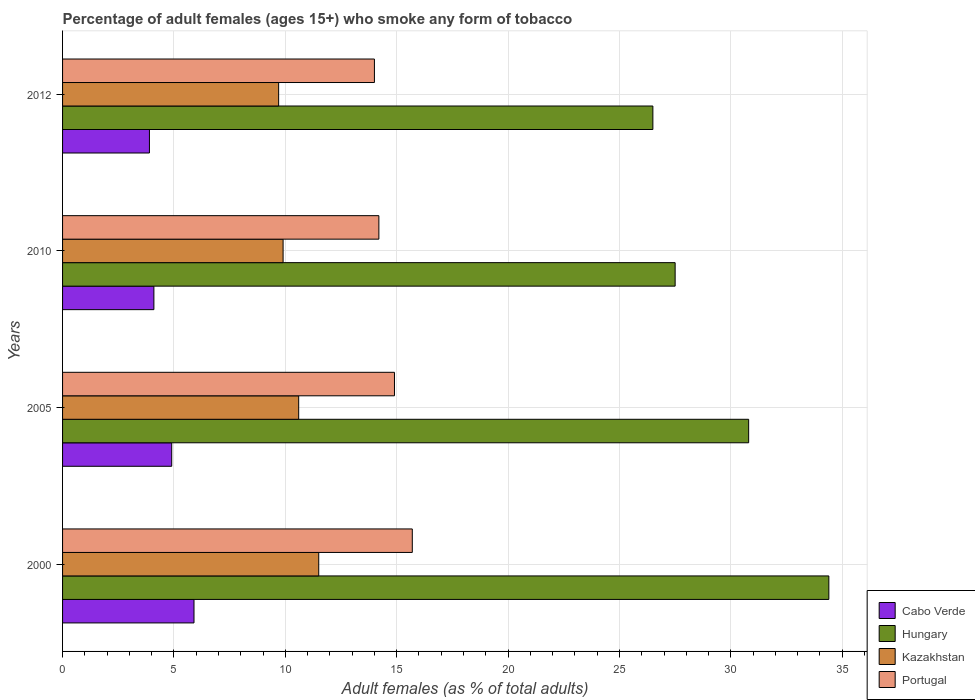How many groups of bars are there?
Provide a short and direct response. 4. How many bars are there on the 1st tick from the bottom?
Offer a terse response. 4. What is the percentage of adult females who smoke in Cabo Verde in 2005?
Keep it short and to the point. 4.9. Across all years, what is the maximum percentage of adult females who smoke in Hungary?
Your answer should be compact. 34.4. In which year was the percentage of adult females who smoke in Kazakhstan maximum?
Your answer should be very brief. 2000. What is the total percentage of adult females who smoke in Portugal in the graph?
Your response must be concise. 58.8. What is the difference between the percentage of adult females who smoke in Kazakhstan in 2005 and that in 2010?
Your answer should be compact. 0.7. What is the difference between the percentage of adult females who smoke in Hungary in 2005 and the percentage of adult females who smoke in Kazakhstan in 2012?
Give a very brief answer. 21.1. What is the average percentage of adult females who smoke in Hungary per year?
Ensure brevity in your answer.  29.8. In the year 2005, what is the difference between the percentage of adult females who smoke in Kazakhstan and percentage of adult females who smoke in Hungary?
Provide a succinct answer. -20.2. In how many years, is the percentage of adult females who smoke in Hungary greater than 14 %?
Provide a succinct answer. 4. What is the ratio of the percentage of adult females who smoke in Portugal in 2005 to that in 2010?
Offer a very short reply. 1.05. Is the percentage of adult females who smoke in Cabo Verde in 2005 less than that in 2012?
Make the answer very short. No. Is the difference between the percentage of adult females who smoke in Kazakhstan in 2000 and 2010 greater than the difference between the percentage of adult females who smoke in Hungary in 2000 and 2010?
Your response must be concise. No. What is the difference between the highest and the lowest percentage of adult females who smoke in Hungary?
Offer a terse response. 7.9. Is it the case that in every year, the sum of the percentage of adult females who smoke in Hungary and percentage of adult females who smoke in Portugal is greater than the sum of percentage of adult females who smoke in Cabo Verde and percentage of adult females who smoke in Kazakhstan?
Provide a short and direct response. No. What does the 2nd bar from the top in 2012 represents?
Make the answer very short. Kazakhstan. Is it the case that in every year, the sum of the percentage of adult females who smoke in Hungary and percentage of adult females who smoke in Cabo Verde is greater than the percentage of adult females who smoke in Kazakhstan?
Give a very brief answer. Yes. How many bars are there?
Make the answer very short. 16. Are the values on the major ticks of X-axis written in scientific E-notation?
Make the answer very short. No. Does the graph contain any zero values?
Offer a terse response. No. Where does the legend appear in the graph?
Provide a succinct answer. Bottom right. What is the title of the graph?
Provide a short and direct response. Percentage of adult females (ages 15+) who smoke any form of tobacco. Does "Cayman Islands" appear as one of the legend labels in the graph?
Your response must be concise. No. What is the label or title of the X-axis?
Offer a very short reply. Adult females (as % of total adults). What is the label or title of the Y-axis?
Make the answer very short. Years. What is the Adult females (as % of total adults) in Hungary in 2000?
Ensure brevity in your answer.  34.4. What is the Adult females (as % of total adults) of Kazakhstan in 2000?
Offer a terse response. 11.5. What is the Adult females (as % of total adults) of Cabo Verde in 2005?
Your answer should be very brief. 4.9. What is the Adult females (as % of total adults) of Hungary in 2005?
Keep it short and to the point. 30.8. What is the Adult females (as % of total adults) of Cabo Verde in 2010?
Ensure brevity in your answer.  4.1. What is the Adult females (as % of total adults) of Kazakhstan in 2010?
Your response must be concise. 9.9. What is the Adult females (as % of total adults) in Cabo Verde in 2012?
Make the answer very short. 3.9. What is the Adult females (as % of total adults) of Portugal in 2012?
Provide a short and direct response. 14. Across all years, what is the maximum Adult females (as % of total adults) of Cabo Verde?
Your response must be concise. 5.9. Across all years, what is the maximum Adult females (as % of total adults) of Hungary?
Your answer should be very brief. 34.4. Across all years, what is the minimum Adult females (as % of total adults) in Cabo Verde?
Provide a short and direct response. 3.9. Across all years, what is the minimum Adult females (as % of total adults) in Hungary?
Your answer should be very brief. 26.5. What is the total Adult females (as % of total adults) of Cabo Verde in the graph?
Keep it short and to the point. 18.8. What is the total Adult females (as % of total adults) of Hungary in the graph?
Your response must be concise. 119.2. What is the total Adult females (as % of total adults) in Kazakhstan in the graph?
Make the answer very short. 41.7. What is the total Adult females (as % of total adults) in Portugal in the graph?
Offer a very short reply. 58.8. What is the difference between the Adult females (as % of total adults) in Cabo Verde in 2000 and that in 2005?
Offer a very short reply. 1. What is the difference between the Adult females (as % of total adults) in Hungary in 2000 and that in 2010?
Your answer should be compact. 6.9. What is the difference between the Adult females (as % of total adults) in Cabo Verde in 2000 and that in 2012?
Provide a short and direct response. 2. What is the difference between the Adult females (as % of total adults) of Portugal in 2005 and that in 2010?
Your response must be concise. 0.7. What is the difference between the Adult females (as % of total adults) of Cabo Verde in 2005 and that in 2012?
Provide a succinct answer. 1. What is the difference between the Adult females (as % of total adults) of Hungary in 2005 and that in 2012?
Ensure brevity in your answer.  4.3. What is the difference between the Adult females (as % of total adults) in Portugal in 2005 and that in 2012?
Make the answer very short. 0.9. What is the difference between the Adult females (as % of total adults) in Hungary in 2010 and that in 2012?
Your response must be concise. 1. What is the difference between the Adult females (as % of total adults) of Kazakhstan in 2010 and that in 2012?
Your answer should be very brief. 0.2. What is the difference between the Adult females (as % of total adults) in Portugal in 2010 and that in 2012?
Provide a succinct answer. 0.2. What is the difference between the Adult females (as % of total adults) in Cabo Verde in 2000 and the Adult females (as % of total adults) in Hungary in 2005?
Provide a short and direct response. -24.9. What is the difference between the Adult females (as % of total adults) of Cabo Verde in 2000 and the Adult females (as % of total adults) of Portugal in 2005?
Offer a very short reply. -9. What is the difference between the Adult females (as % of total adults) in Hungary in 2000 and the Adult females (as % of total adults) in Kazakhstan in 2005?
Provide a succinct answer. 23.8. What is the difference between the Adult females (as % of total adults) in Hungary in 2000 and the Adult females (as % of total adults) in Portugal in 2005?
Ensure brevity in your answer.  19.5. What is the difference between the Adult females (as % of total adults) in Kazakhstan in 2000 and the Adult females (as % of total adults) in Portugal in 2005?
Provide a short and direct response. -3.4. What is the difference between the Adult females (as % of total adults) in Cabo Verde in 2000 and the Adult females (as % of total adults) in Hungary in 2010?
Keep it short and to the point. -21.6. What is the difference between the Adult females (as % of total adults) in Cabo Verde in 2000 and the Adult females (as % of total adults) in Kazakhstan in 2010?
Your answer should be compact. -4. What is the difference between the Adult females (as % of total adults) in Hungary in 2000 and the Adult females (as % of total adults) in Kazakhstan in 2010?
Your response must be concise. 24.5. What is the difference between the Adult females (as % of total adults) in Hungary in 2000 and the Adult females (as % of total adults) in Portugal in 2010?
Your answer should be very brief. 20.2. What is the difference between the Adult females (as % of total adults) of Cabo Verde in 2000 and the Adult females (as % of total adults) of Hungary in 2012?
Offer a terse response. -20.6. What is the difference between the Adult females (as % of total adults) of Cabo Verde in 2000 and the Adult females (as % of total adults) of Portugal in 2012?
Provide a short and direct response. -8.1. What is the difference between the Adult females (as % of total adults) in Hungary in 2000 and the Adult females (as % of total adults) in Kazakhstan in 2012?
Offer a terse response. 24.7. What is the difference between the Adult females (as % of total adults) in Hungary in 2000 and the Adult females (as % of total adults) in Portugal in 2012?
Keep it short and to the point. 20.4. What is the difference between the Adult females (as % of total adults) of Cabo Verde in 2005 and the Adult females (as % of total adults) of Hungary in 2010?
Your answer should be very brief. -22.6. What is the difference between the Adult females (as % of total adults) of Cabo Verde in 2005 and the Adult females (as % of total adults) of Kazakhstan in 2010?
Make the answer very short. -5. What is the difference between the Adult females (as % of total adults) of Cabo Verde in 2005 and the Adult females (as % of total adults) of Portugal in 2010?
Provide a short and direct response. -9.3. What is the difference between the Adult females (as % of total adults) of Hungary in 2005 and the Adult females (as % of total adults) of Kazakhstan in 2010?
Ensure brevity in your answer.  20.9. What is the difference between the Adult females (as % of total adults) in Hungary in 2005 and the Adult females (as % of total adults) in Portugal in 2010?
Provide a short and direct response. 16.6. What is the difference between the Adult females (as % of total adults) in Cabo Verde in 2005 and the Adult females (as % of total adults) in Hungary in 2012?
Make the answer very short. -21.6. What is the difference between the Adult females (as % of total adults) in Cabo Verde in 2005 and the Adult females (as % of total adults) in Kazakhstan in 2012?
Make the answer very short. -4.8. What is the difference between the Adult females (as % of total adults) of Cabo Verde in 2005 and the Adult females (as % of total adults) of Portugal in 2012?
Keep it short and to the point. -9.1. What is the difference between the Adult females (as % of total adults) of Hungary in 2005 and the Adult females (as % of total adults) of Kazakhstan in 2012?
Your response must be concise. 21.1. What is the difference between the Adult females (as % of total adults) of Cabo Verde in 2010 and the Adult females (as % of total adults) of Hungary in 2012?
Offer a very short reply. -22.4. What is the difference between the Adult females (as % of total adults) of Cabo Verde in 2010 and the Adult females (as % of total adults) of Portugal in 2012?
Make the answer very short. -9.9. What is the difference between the Adult females (as % of total adults) of Hungary in 2010 and the Adult females (as % of total adults) of Kazakhstan in 2012?
Your answer should be very brief. 17.8. What is the difference between the Adult females (as % of total adults) in Kazakhstan in 2010 and the Adult females (as % of total adults) in Portugal in 2012?
Provide a succinct answer. -4.1. What is the average Adult females (as % of total adults) of Cabo Verde per year?
Give a very brief answer. 4.7. What is the average Adult females (as % of total adults) of Hungary per year?
Provide a succinct answer. 29.8. What is the average Adult females (as % of total adults) of Kazakhstan per year?
Offer a very short reply. 10.43. In the year 2000, what is the difference between the Adult females (as % of total adults) of Cabo Verde and Adult females (as % of total adults) of Hungary?
Provide a succinct answer. -28.5. In the year 2000, what is the difference between the Adult females (as % of total adults) of Cabo Verde and Adult females (as % of total adults) of Kazakhstan?
Ensure brevity in your answer.  -5.6. In the year 2000, what is the difference between the Adult females (as % of total adults) of Hungary and Adult females (as % of total adults) of Kazakhstan?
Offer a terse response. 22.9. In the year 2000, what is the difference between the Adult females (as % of total adults) of Hungary and Adult females (as % of total adults) of Portugal?
Give a very brief answer. 18.7. In the year 2005, what is the difference between the Adult females (as % of total adults) of Cabo Verde and Adult females (as % of total adults) of Hungary?
Your answer should be compact. -25.9. In the year 2005, what is the difference between the Adult females (as % of total adults) of Cabo Verde and Adult females (as % of total adults) of Kazakhstan?
Make the answer very short. -5.7. In the year 2005, what is the difference between the Adult females (as % of total adults) of Hungary and Adult females (as % of total adults) of Kazakhstan?
Offer a very short reply. 20.2. In the year 2005, what is the difference between the Adult females (as % of total adults) of Hungary and Adult females (as % of total adults) of Portugal?
Provide a short and direct response. 15.9. In the year 2010, what is the difference between the Adult females (as % of total adults) of Cabo Verde and Adult females (as % of total adults) of Hungary?
Your answer should be compact. -23.4. In the year 2010, what is the difference between the Adult females (as % of total adults) of Cabo Verde and Adult females (as % of total adults) of Kazakhstan?
Give a very brief answer. -5.8. In the year 2010, what is the difference between the Adult females (as % of total adults) of Hungary and Adult females (as % of total adults) of Kazakhstan?
Keep it short and to the point. 17.6. In the year 2010, what is the difference between the Adult females (as % of total adults) in Hungary and Adult females (as % of total adults) in Portugal?
Offer a very short reply. 13.3. In the year 2012, what is the difference between the Adult females (as % of total adults) in Cabo Verde and Adult females (as % of total adults) in Hungary?
Offer a very short reply. -22.6. In the year 2012, what is the difference between the Adult females (as % of total adults) in Cabo Verde and Adult females (as % of total adults) in Portugal?
Provide a succinct answer. -10.1. In the year 2012, what is the difference between the Adult females (as % of total adults) of Hungary and Adult females (as % of total adults) of Portugal?
Ensure brevity in your answer.  12.5. What is the ratio of the Adult females (as % of total adults) of Cabo Verde in 2000 to that in 2005?
Your answer should be very brief. 1.2. What is the ratio of the Adult females (as % of total adults) of Hungary in 2000 to that in 2005?
Provide a succinct answer. 1.12. What is the ratio of the Adult females (as % of total adults) in Kazakhstan in 2000 to that in 2005?
Your answer should be compact. 1.08. What is the ratio of the Adult females (as % of total adults) of Portugal in 2000 to that in 2005?
Your response must be concise. 1.05. What is the ratio of the Adult females (as % of total adults) of Cabo Verde in 2000 to that in 2010?
Provide a short and direct response. 1.44. What is the ratio of the Adult females (as % of total adults) in Hungary in 2000 to that in 2010?
Provide a succinct answer. 1.25. What is the ratio of the Adult females (as % of total adults) of Kazakhstan in 2000 to that in 2010?
Provide a succinct answer. 1.16. What is the ratio of the Adult females (as % of total adults) of Portugal in 2000 to that in 2010?
Your answer should be compact. 1.11. What is the ratio of the Adult females (as % of total adults) in Cabo Verde in 2000 to that in 2012?
Your response must be concise. 1.51. What is the ratio of the Adult females (as % of total adults) in Hungary in 2000 to that in 2012?
Your answer should be very brief. 1.3. What is the ratio of the Adult females (as % of total adults) in Kazakhstan in 2000 to that in 2012?
Your answer should be compact. 1.19. What is the ratio of the Adult females (as % of total adults) of Portugal in 2000 to that in 2012?
Offer a very short reply. 1.12. What is the ratio of the Adult females (as % of total adults) of Cabo Verde in 2005 to that in 2010?
Make the answer very short. 1.2. What is the ratio of the Adult females (as % of total adults) of Hungary in 2005 to that in 2010?
Your answer should be very brief. 1.12. What is the ratio of the Adult females (as % of total adults) of Kazakhstan in 2005 to that in 2010?
Make the answer very short. 1.07. What is the ratio of the Adult females (as % of total adults) of Portugal in 2005 to that in 2010?
Offer a terse response. 1.05. What is the ratio of the Adult females (as % of total adults) of Cabo Verde in 2005 to that in 2012?
Ensure brevity in your answer.  1.26. What is the ratio of the Adult females (as % of total adults) of Hungary in 2005 to that in 2012?
Offer a very short reply. 1.16. What is the ratio of the Adult females (as % of total adults) of Kazakhstan in 2005 to that in 2012?
Your answer should be compact. 1.09. What is the ratio of the Adult females (as % of total adults) in Portugal in 2005 to that in 2012?
Your answer should be very brief. 1.06. What is the ratio of the Adult females (as % of total adults) of Cabo Verde in 2010 to that in 2012?
Provide a succinct answer. 1.05. What is the ratio of the Adult females (as % of total adults) in Hungary in 2010 to that in 2012?
Give a very brief answer. 1.04. What is the ratio of the Adult females (as % of total adults) in Kazakhstan in 2010 to that in 2012?
Provide a succinct answer. 1.02. What is the ratio of the Adult females (as % of total adults) of Portugal in 2010 to that in 2012?
Give a very brief answer. 1.01. What is the difference between the highest and the second highest Adult females (as % of total adults) of Hungary?
Provide a succinct answer. 3.6. What is the difference between the highest and the second highest Adult females (as % of total adults) of Kazakhstan?
Offer a terse response. 0.9. What is the difference between the highest and the second highest Adult females (as % of total adults) in Portugal?
Offer a terse response. 0.8. What is the difference between the highest and the lowest Adult females (as % of total adults) in Cabo Verde?
Offer a terse response. 2. 